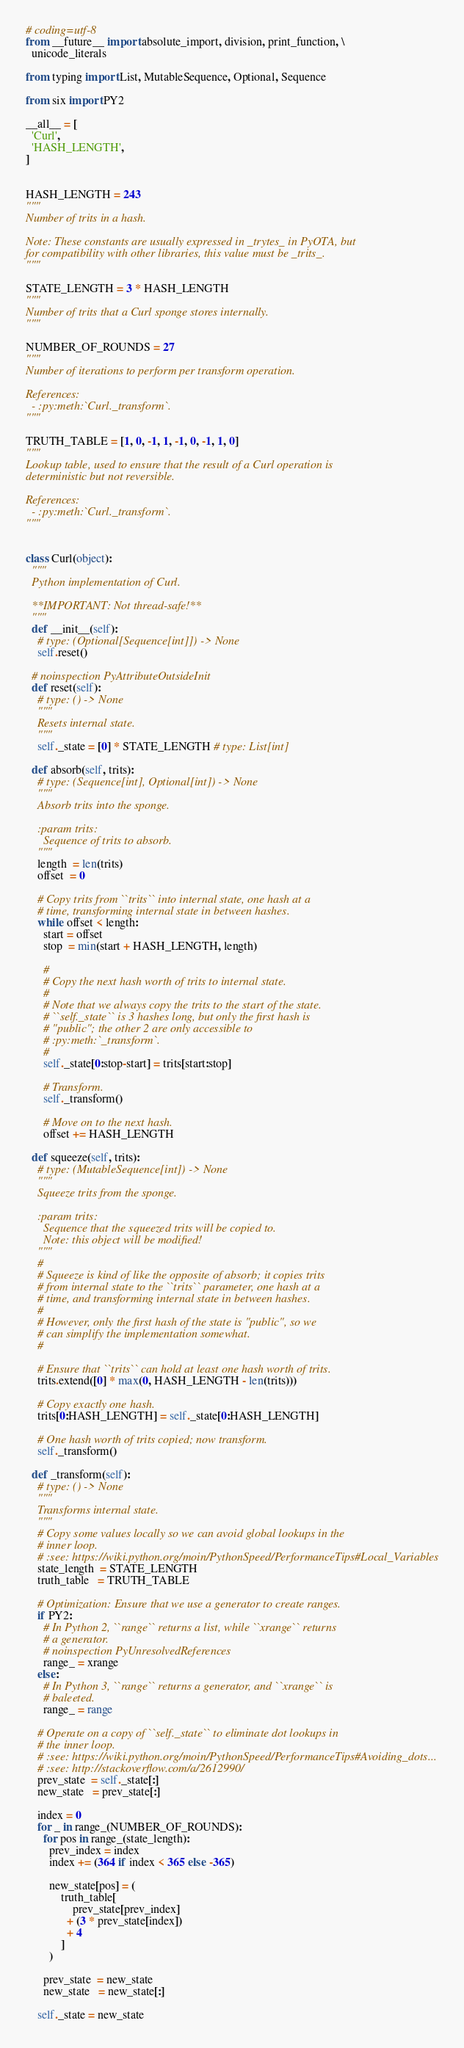<code> <loc_0><loc_0><loc_500><loc_500><_Python_># coding=utf-8
from __future__ import absolute_import, division, print_function, \
  unicode_literals

from typing import List, MutableSequence, Optional, Sequence

from six import PY2

__all__ = [
  'Curl',
  'HASH_LENGTH',
]


HASH_LENGTH = 243
"""
Number of trits in a hash.

Note: These constants are usually expressed in _trytes_ in PyOTA, but
for compatibility with other libraries, this value must be _trits_.
"""

STATE_LENGTH = 3 * HASH_LENGTH
"""
Number of trits that a Curl sponge stores internally.
"""

NUMBER_OF_ROUNDS = 27
"""
Number of iterations to perform per transform operation.

References:
  - :py:meth:`Curl._transform`.
"""

TRUTH_TABLE = [1, 0, -1, 1, -1, 0, -1, 1, 0]
"""
Lookup table, used to ensure that the result of a Curl operation is
deterministic but not reversible.

References:
  - :py:meth:`Curl._transform`.
"""


class Curl(object):
  """
  Python implementation of Curl.

  **IMPORTANT: Not thread-safe!**
  """
  def __init__(self):
    # type: (Optional[Sequence[int]]) -> None
    self.reset()

  # noinspection PyAttributeOutsideInit
  def reset(self):
    # type: () -> None
    """
    Resets internal state.
    """
    self._state = [0] * STATE_LENGTH # type: List[int]

  def absorb(self, trits):
    # type: (Sequence[int], Optional[int]) -> None
    """
    Absorb trits into the sponge.

    :param trits:
      Sequence of trits to absorb.
    """
    length  = len(trits)
    offset  = 0

    # Copy trits from ``trits`` into internal state, one hash at a
    # time, transforming internal state in between hashes.
    while offset < length:
      start = offset
      stop  = min(start + HASH_LENGTH, length)

      #
      # Copy the next hash worth of trits to internal state.
      #
      # Note that we always copy the trits to the start of the state.
      # ``self._state`` is 3 hashes long, but only the first hash is
      # "public"; the other 2 are only accessible to
      # :py:meth:`_transform`.
      #
      self._state[0:stop-start] = trits[start:stop]

      # Transform.
      self._transform()

      # Move on to the next hash.
      offset += HASH_LENGTH

  def squeeze(self, trits):
    # type: (MutableSequence[int]) -> None
    """
    Squeeze trits from the sponge.

    :param trits:
      Sequence that the squeezed trits will be copied to.
      Note: this object will be modified!
    """
    #
    # Squeeze is kind of like the opposite of absorb; it copies trits
    # from internal state to the ``trits`` parameter, one hash at a
    # time, and transforming internal state in between hashes.
    #
    # However, only the first hash of the state is "public", so we
    # can simplify the implementation somewhat.
    #

    # Ensure that ``trits`` can hold at least one hash worth of trits.
    trits.extend([0] * max(0, HASH_LENGTH - len(trits)))

    # Copy exactly one hash.
    trits[0:HASH_LENGTH] = self._state[0:HASH_LENGTH]

    # One hash worth of trits copied; now transform.
    self._transform()

  def _transform(self):
    # type: () -> None
    """
    Transforms internal state.
    """
    # Copy some values locally so we can avoid global lookups in the
    # inner loop.
    # :see: https://wiki.python.org/moin/PythonSpeed/PerformanceTips#Local_Variables
    state_length  = STATE_LENGTH
    truth_table   = TRUTH_TABLE

    # Optimization: Ensure that we use a generator to create ranges.
    if PY2:
      # In Python 2, ``range`` returns a list, while ``xrange`` returns
      # a generator.
      # noinspection PyUnresolvedReferences
      range_ = xrange
    else:
      # In Python 3, ``range`` returns a generator, and ``xrange`` is
      # baleeted.
      range_ = range

    # Operate on a copy of ``self._state`` to eliminate dot lookups in
    # the inner loop.
    # :see: https://wiki.python.org/moin/PythonSpeed/PerformanceTips#Avoiding_dots...
    # :see: http://stackoverflow.com/a/2612990/
    prev_state  = self._state[:]
    new_state   = prev_state[:]

    index = 0
    for _ in range_(NUMBER_OF_ROUNDS):
      for pos in range_(state_length):
        prev_index = index
        index += (364 if index < 365 else -365)

        new_state[pos] = (
            truth_table[
                prev_state[prev_index]
              + (3 * prev_state[index])
              + 4
            ]
        )

      prev_state  = new_state
      new_state   = new_state[:]

    self._state = new_state
</code> 